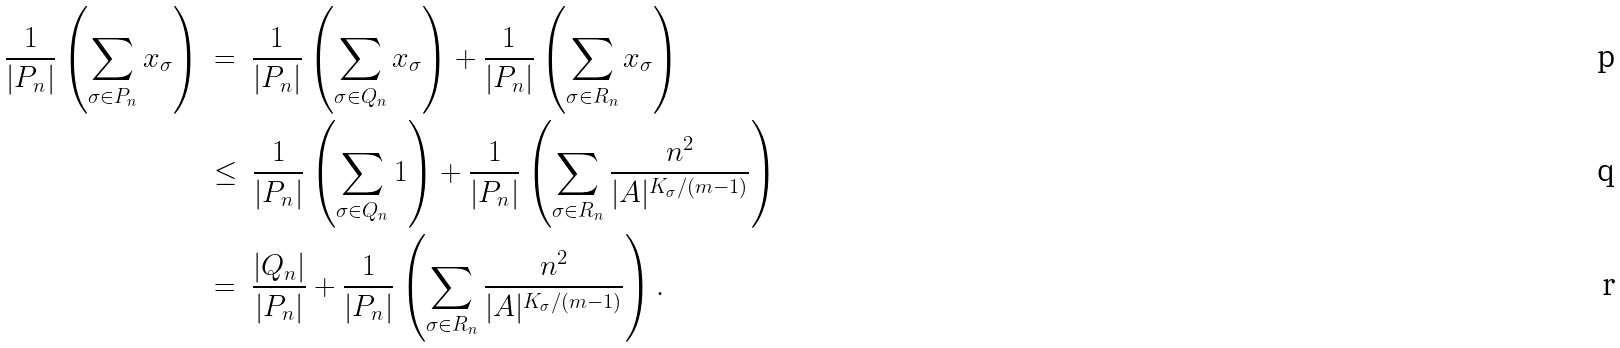<formula> <loc_0><loc_0><loc_500><loc_500>\frac { 1 } { | P _ { n } | } \left ( \sum _ { \sigma \in P _ { n } } x _ { \sigma } \right ) \ & = \ \frac { 1 } { | P _ { n } | } \left ( \sum _ { \sigma \in Q _ { n } } x _ { \sigma } \right ) + \frac { 1 } { | P _ { n } | } \left ( \sum _ { \sigma \in R _ { n } } x _ { \sigma } \right ) \\ & \leq \ \frac { 1 } { | P _ { n } | } \left ( \sum _ { \sigma \in Q _ { n } } 1 \right ) + \frac { 1 } { | P _ { n } | } \left ( \sum _ { \sigma \in R _ { n } } \frac { n ^ { 2 } } { | A | ^ { K _ { \sigma } / ( m - 1 ) } } \right ) \\ & = \ \frac { | Q _ { n } | } { | P _ { n } | } + \frac { 1 } { | P _ { n } | } \left ( \sum _ { \sigma \in R _ { n } } \frac { n ^ { 2 } } { | A | ^ { K _ { \sigma } / ( m - 1 ) } } \right ) .</formula> 